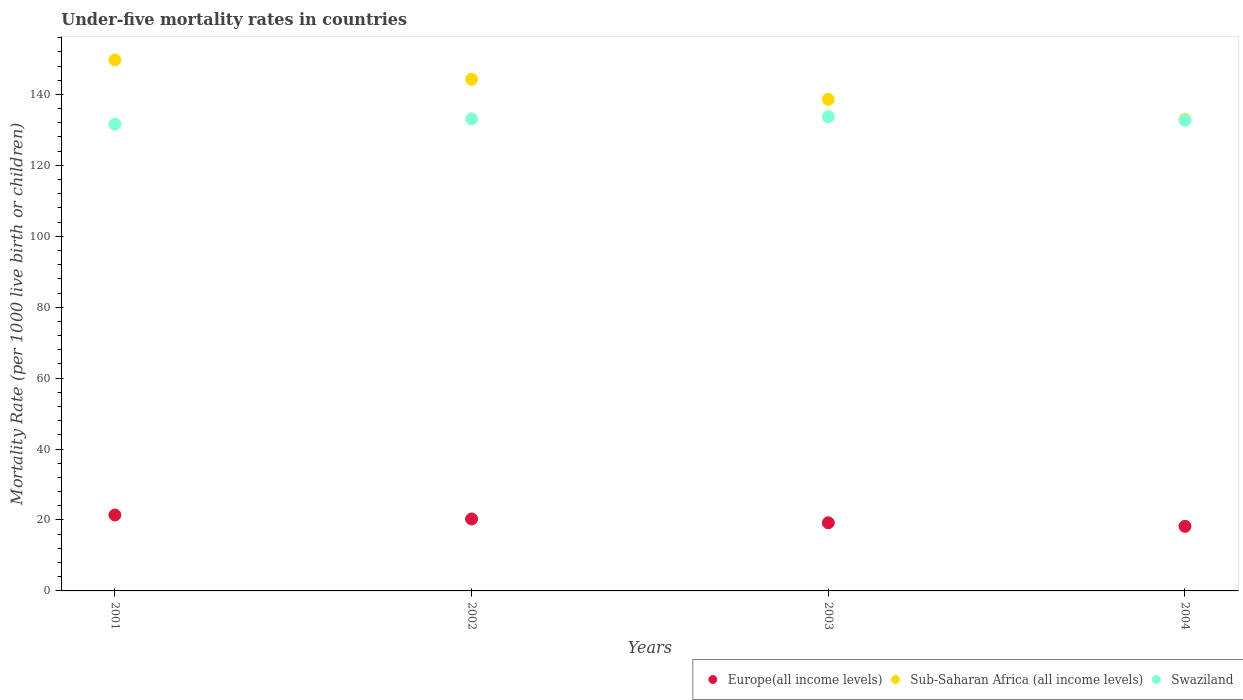How many different coloured dotlines are there?
Provide a succinct answer. 3. Is the number of dotlines equal to the number of legend labels?
Provide a succinct answer. Yes. What is the under-five mortality rate in Europe(all income levels) in 2001?
Offer a terse response. 21.41. Across all years, what is the maximum under-five mortality rate in Europe(all income levels)?
Ensure brevity in your answer.  21.41. Across all years, what is the minimum under-five mortality rate in Swaziland?
Provide a short and direct response. 131.6. In which year was the under-five mortality rate in Europe(all income levels) maximum?
Make the answer very short. 2001. In which year was the under-five mortality rate in Europe(all income levels) minimum?
Offer a terse response. 2004. What is the total under-five mortality rate in Europe(all income levels) in the graph?
Offer a terse response. 79.12. What is the difference between the under-five mortality rate in Sub-Saharan Africa (all income levels) in 2001 and that in 2004?
Your answer should be compact. 16.84. What is the difference between the under-five mortality rate in Sub-Saharan Africa (all income levels) in 2004 and the under-five mortality rate in Swaziland in 2003?
Give a very brief answer. -0.8. What is the average under-five mortality rate in Swaziland per year?
Provide a succinct answer. 132.77. In the year 2001, what is the difference between the under-five mortality rate in Europe(all income levels) and under-five mortality rate in Sub-Saharan Africa (all income levels)?
Provide a succinct answer. -128.33. In how many years, is the under-five mortality rate in Europe(all income levels) greater than 44?
Ensure brevity in your answer.  0. What is the ratio of the under-five mortality rate in Sub-Saharan Africa (all income levels) in 2002 to that in 2003?
Your answer should be very brief. 1.04. What is the difference between the highest and the second highest under-five mortality rate in Europe(all income levels)?
Provide a short and direct response. 1.12. What is the difference between the highest and the lowest under-five mortality rate in Sub-Saharan Africa (all income levels)?
Offer a terse response. 16.84. In how many years, is the under-five mortality rate in Swaziland greater than the average under-five mortality rate in Swaziland taken over all years?
Offer a terse response. 2. Is it the case that in every year, the sum of the under-five mortality rate in Swaziland and under-five mortality rate in Sub-Saharan Africa (all income levels)  is greater than the under-five mortality rate in Europe(all income levels)?
Ensure brevity in your answer.  Yes. Does the under-five mortality rate in Sub-Saharan Africa (all income levels) monotonically increase over the years?
Give a very brief answer. No. Is the under-five mortality rate in Swaziland strictly less than the under-five mortality rate in Sub-Saharan Africa (all income levels) over the years?
Offer a terse response. Yes. How many dotlines are there?
Make the answer very short. 3. How many years are there in the graph?
Keep it short and to the point. 4. Does the graph contain any zero values?
Give a very brief answer. No. How many legend labels are there?
Make the answer very short. 3. How are the legend labels stacked?
Keep it short and to the point. Horizontal. What is the title of the graph?
Your response must be concise. Under-five mortality rates in countries. What is the label or title of the Y-axis?
Your response must be concise. Mortality Rate (per 1000 live birth or children). What is the Mortality Rate (per 1000 live birth or children) in Europe(all income levels) in 2001?
Ensure brevity in your answer.  21.41. What is the Mortality Rate (per 1000 live birth or children) of Sub-Saharan Africa (all income levels) in 2001?
Your answer should be compact. 149.74. What is the Mortality Rate (per 1000 live birth or children) in Swaziland in 2001?
Provide a short and direct response. 131.6. What is the Mortality Rate (per 1000 live birth or children) of Europe(all income levels) in 2002?
Keep it short and to the point. 20.29. What is the Mortality Rate (per 1000 live birth or children) of Sub-Saharan Africa (all income levels) in 2002?
Your response must be concise. 144.27. What is the Mortality Rate (per 1000 live birth or children) of Swaziland in 2002?
Provide a short and direct response. 133.1. What is the Mortality Rate (per 1000 live birth or children) in Europe(all income levels) in 2003?
Make the answer very short. 19.22. What is the Mortality Rate (per 1000 live birth or children) of Sub-Saharan Africa (all income levels) in 2003?
Give a very brief answer. 138.61. What is the Mortality Rate (per 1000 live birth or children) in Swaziland in 2003?
Keep it short and to the point. 133.7. What is the Mortality Rate (per 1000 live birth or children) of Europe(all income levels) in 2004?
Ensure brevity in your answer.  18.21. What is the Mortality Rate (per 1000 live birth or children) in Sub-Saharan Africa (all income levels) in 2004?
Ensure brevity in your answer.  132.9. What is the Mortality Rate (per 1000 live birth or children) of Swaziland in 2004?
Give a very brief answer. 132.7. Across all years, what is the maximum Mortality Rate (per 1000 live birth or children) of Europe(all income levels)?
Provide a succinct answer. 21.41. Across all years, what is the maximum Mortality Rate (per 1000 live birth or children) in Sub-Saharan Africa (all income levels)?
Keep it short and to the point. 149.74. Across all years, what is the maximum Mortality Rate (per 1000 live birth or children) of Swaziland?
Give a very brief answer. 133.7. Across all years, what is the minimum Mortality Rate (per 1000 live birth or children) of Europe(all income levels)?
Offer a terse response. 18.21. Across all years, what is the minimum Mortality Rate (per 1000 live birth or children) of Sub-Saharan Africa (all income levels)?
Provide a short and direct response. 132.9. Across all years, what is the minimum Mortality Rate (per 1000 live birth or children) of Swaziland?
Keep it short and to the point. 131.6. What is the total Mortality Rate (per 1000 live birth or children) in Europe(all income levels) in the graph?
Give a very brief answer. 79.12. What is the total Mortality Rate (per 1000 live birth or children) in Sub-Saharan Africa (all income levels) in the graph?
Ensure brevity in your answer.  565.52. What is the total Mortality Rate (per 1000 live birth or children) of Swaziland in the graph?
Provide a short and direct response. 531.1. What is the difference between the Mortality Rate (per 1000 live birth or children) in Europe(all income levels) in 2001 and that in 2002?
Your answer should be compact. 1.12. What is the difference between the Mortality Rate (per 1000 live birth or children) of Sub-Saharan Africa (all income levels) in 2001 and that in 2002?
Give a very brief answer. 5.47. What is the difference between the Mortality Rate (per 1000 live birth or children) in Swaziland in 2001 and that in 2002?
Your response must be concise. -1.5. What is the difference between the Mortality Rate (per 1000 live birth or children) in Europe(all income levels) in 2001 and that in 2003?
Give a very brief answer. 2.19. What is the difference between the Mortality Rate (per 1000 live birth or children) of Sub-Saharan Africa (all income levels) in 2001 and that in 2003?
Keep it short and to the point. 11.13. What is the difference between the Mortality Rate (per 1000 live birth or children) of Europe(all income levels) in 2001 and that in 2004?
Keep it short and to the point. 3.2. What is the difference between the Mortality Rate (per 1000 live birth or children) of Sub-Saharan Africa (all income levels) in 2001 and that in 2004?
Give a very brief answer. 16.84. What is the difference between the Mortality Rate (per 1000 live birth or children) in Swaziland in 2001 and that in 2004?
Your answer should be very brief. -1.1. What is the difference between the Mortality Rate (per 1000 live birth or children) of Europe(all income levels) in 2002 and that in 2003?
Your answer should be compact. 1.07. What is the difference between the Mortality Rate (per 1000 live birth or children) in Sub-Saharan Africa (all income levels) in 2002 and that in 2003?
Ensure brevity in your answer.  5.66. What is the difference between the Mortality Rate (per 1000 live birth or children) in Europe(all income levels) in 2002 and that in 2004?
Give a very brief answer. 2.09. What is the difference between the Mortality Rate (per 1000 live birth or children) of Sub-Saharan Africa (all income levels) in 2002 and that in 2004?
Your response must be concise. 11.37. What is the difference between the Mortality Rate (per 1000 live birth or children) of Swaziland in 2002 and that in 2004?
Keep it short and to the point. 0.4. What is the difference between the Mortality Rate (per 1000 live birth or children) in Europe(all income levels) in 2003 and that in 2004?
Provide a succinct answer. 1.01. What is the difference between the Mortality Rate (per 1000 live birth or children) in Sub-Saharan Africa (all income levels) in 2003 and that in 2004?
Give a very brief answer. 5.72. What is the difference between the Mortality Rate (per 1000 live birth or children) in Europe(all income levels) in 2001 and the Mortality Rate (per 1000 live birth or children) in Sub-Saharan Africa (all income levels) in 2002?
Give a very brief answer. -122.86. What is the difference between the Mortality Rate (per 1000 live birth or children) of Europe(all income levels) in 2001 and the Mortality Rate (per 1000 live birth or children) of Swaziland in 2002?
Offer a terse response. -111.69. What is the difference between the Mortality Rate (per 1000 live birth or children) in Sub-Saharan Africa (all income levels) in 2001 and the Mortality Rate (per 1000 live birth or children) in Swaziland in 2002?
Keep it short and to the point. 16.64. What is the difference between the Mortality Rate (per 1000 live birth or children) in Europe(all income levels) in 2001 and the Mortality Rate (per 1000 live birth or children) in Sub-Saharan Africa (all income levels) in 2003?
Provide a succinct answer. -117.2. What is the difference between the Mortality Rate (per 1000 live birth or children) of Europe(all income levels) in 2001 and the Mortality Rate (per 1000 live birth or children) of Swaziland in 2003?
Ensure brevity in your answer.  -112.29. What is the difference between the Mortality Rate (per 1000 live birth or children) in Sub-Saharan Africa (all income levels) in 2001 and the Mortality Rate (per 1000 live birth or children) in Swaziland in 2003?
Your response must be concise. 16.04. What is the difference between the Mortality Rate (per 1000 live birth or children) of Europe(all income levels) in 2001 and the Mortality Rate (per 1000 live birth or children) of Sub-Saharan Africa (all income levels) in 2004?
Your response must be concise. -111.49. What is the difference between the Mortality Rate (per 1000 live birth or children) in Europe(all income levels) in 2001 and the Mortality Rate (per 1000 live birth or children) in Swaziland in 2004?
Make the answer very short. -111.29. What is the difference between the Mortality Rate (per 1000 live birth or children) of Sub-Saharan Africa (all income levels) in 2001 and the Mortality Rate (per 1000 live birth or children) of Swaziland in 2004?
Make the answer very short. 17.04. What is the difference between the Mortality Rate (per 1000 live birth or children) in Europe(all income levels) in 2002 and the Mortality Rate (per 1000 live birth or children) in Sub-Saharan Africa (all income levels) in 2003?
Give a very brief answer. -118.32. What is the difference between the Mortality Rate (per 1000 live birth or children) of Europe(all income levels) in 2002 and the Mortality Rate (per 1000 live birth or children) of Swaziland in 2003?
Ensure brevity in your answer.  -113.41. What is the difference between the Mortality Rate (per 1000 live birth or children) of Sub-Saharan Africa (all income levels) in 2002 and the Mortality Rate (per 1000 live birth or children) of Swaziland in 2003?
Keep it short and to the point. 10.57. What is the difference between the Mortality Rate (per 1000 live birth or children) of Europe(all income levels) in 2002 and the Mortality Rate (per 1000 live birth or children) of Sub-Saharan Africa (all income levels) in 2004?
Keep it short and to the point. -112.61. What is the difference between the Mortality Rate (per 1000 live birth or children) in Europe(all income levels) in 2002 and the Mortality Rate (per 1000 live birth or children) in Swaziland in 2004?
Keep it short and to the point. -112.41. What is the difference between the Mortality Rate (per 1000 live birth or children) in Sub-Saharan Africa (all income levels) in 2002 and the Mortality Rate (per 1000 live birth or children) in Swaziland in 2004?
Ensure brevity in your answer.  11.57. What is the difference between the Mortality Rate (per 1000 live birth or children) in Europe(all income levels) in 2003 and the Mortality Rate (per 1000 live birth or children) in Sub-Saharan Africa (all income levels) in 2004?
Your response must be concise. -113.68. What is the difference between the Mortality Rate (per 1000 live birth or children) of Europe(all income levels) in 2003 and the Mortality Rate (per 1000 live birth or children) of Swaziland in 2004?
Give a very brief answer. -113.48. What is the difference between the Mortality Rate (per 1000 live birth or children) in Sub-Saharan Africa (all income levels) in 2003 and the Mortality Rate (per 1000 live birth or children) in Swaziland in 2004?
Offer a very short reply. 5.91. What is the average Mortality Rate (per 1000 live birth or children) in Europe(all income levels) per year?
Provide a succinct answer. 19.78. What is the average Mortality Rate (per 1000 live birth or children) of Sub-Saharan Africa (all income levels) per year?
Offer a terse response. 141.38. What is the average Mortality Rate (per 1000 live birth or children) in Swaziland per year?
Your answer should be compact. 132.78. In the year 2001, what is the difference between the Mortality Rate (per 1000 live birth or children) in Europe(all income levels) and Mortality Rate (per 1000 live birth or children) in Sub-Saharan Africa (all income levels)?
Offer a very short reply. -128.33. In the year 2001, what is the difference between the Mortality Rate (per 1000 live birth or children) in Europe(all income levels) and Mortality Rate (per 1000 live birth or children) in Swaziland?
Provide a succinct answer. -110.19. In the year 2001, what is the difference between the Mortality Rate (per 1000 live birth or children) of Sub-Saharan Africa (all income levels) and Mortality Rate (per 1000 live birth or children) of Swaziland?
Keep it short and to the point. 18.14. In the year 2002, what is the difference between the Mortality Rate (per 1000 live birth or children) in Europe(all income levels) and Mortality Rate (per 1000 live birth or children) in Sub-Saharan Africa (all income levels)?
Make the answer very short. -123.98. In the year 2002, what is the difference between the Mortality Rate (per 1000 live birth or children) of Europe(all income levels) and Mortality Rate (per 1000 live birth or children) of Swaziland?
Your answer should be very brief. -112.81. In the year 2002, what is the difference between the Mortality Rate (per 1000 live birth or children) in Sub-Saharan Africa (all income levels) and Mortality Rate (per 1000 live birth or children) in Swaziland?
Make the answer very short. 11.17. In the year 2003, what is the difference between the Mortality Rate (per 1000 live birth or children) of Europe(all income levels) and Mortality Rate (per 1000 live birth or children) of Sub-Saharan Africa (all income levels)?
Make the answer very short. -119.4. In the year 2003, what is the difference between the Mortality Rate (per 1000 live birth or children) of Europe(all income levels) and Mortality Rate (per 1000 live birth or children) of Swaziland?
Offer a terse response. -114.48. In the year 2003, what is the difference between the Mortality Rate (per 1000 live birth or children) in Sub-Saharan Africa (all income levels) and Mortality Rate (per 1000 live birth or children) in Swaziland?
Give a very brief answer. 4.91. In the year 2004, what is the difference between the Mortality Rate (per 1000 live birth or children) in Europe(all income levels) and Mortality Rate (per 1000 live birth or children) in Sub-Saharan Africa (all income levels)?
Your response must be concise. -114.69. In the year 2004, what is the difference between the Mortality Rate (per 1000 live birth or children) of Europe(all income levels) and Mortality Rate (per 1000 live birth or children) of Swaziland?
Your answer should be compact. -114.49. In the year 2004, what is the difference between the Mortality Rate (per 1000 live birth or children) of Sub-Saharan Africa (all income levels) and Mortality Rate (per 1000 live birth or children) of Swaziland?
Provide a succinct answer. 0.2. What is the ratio of the Mortality Rate (per 1000 live birth or children) in Europe(all income levels) in 2001 to that in 2002?
Your answer should be compact. 1.06. What is the ratio of the Mortality Rate (per 1000 live birth or children) in Sub-Saharan Africa (all income levels) in 2001 to that in 2002?
Your answer should be very brief. 1.04. What is the ratio of the Mortality Rate (per 1000 live birth or children) in Swaziland in 2001 to that in 2002?
Give a very brief answer. 0.99. What is the ratio of the Mortality Rate (per 1000 live birth or children) in Europe(all income levels) in 2001 to that in 2003?
Keep it short and to the point. 1.11. What is the ratio of the Mortality Rate (per 1000 live birth or children) in Sub-Saharan Africa (all income levels) in 2001 to that in 2003?
Offer a terse response. 1.08. What is the ratio of the Mortality Rate (per 1000 live birth or children) of Swaziland in 2001 to that in 2003?
Your answer should be compact. 0.98. What is the ratio of the Mortality Rate (per 1000 live birth or children) of Europe(all income levels) in 2001 to that in 2004?
Your response must be concise. 1.18. What is the ratio of the Mortality Rate (per 1000 live birth or children) of Sub-Saharan Africa (all income levels) in 2001 to that in 2004?
Provide a short and direct response. 1.13. What is the ratio of the Mortality Rate (per 1000 live birth or children) in Europe(all income levels) in 2002 to that in 2003?
Your answer should be compact. 1.06. What is the ratio of the Mortality Rate (per 1000 live birth or children) of Sub-Saharan Africa (all income levels) in 2002 to that in 2003?
Make the answer very short. 1.04. What is the ratio of the Mortality Rate (per 1000 live birth or children) in Europe(all income levels) in 2002 to that in 2004?
Give a very brief answer. 1.11. What is the ratio of the Mortality Rate (per 1000 live birth or children) in Sub-Saharan Africa (all income levels) in 2002 to that in 2004?
Provide a succinct answer. 1.09. What is the ratio of the Mortality Rate (per 1000 live birth or children) in Europe(all income levels) in 2003 to that in 2004?
Make the answer very short. 1.06. What is the ratio of the Mortality Rate (per 1000 live birth or children) of Sub-Saharan Africa (all income levels) in 2003 to that in 2004?
Ensure brevity in your answer.  1.04. What is the ratio of the Mortality Rate (per 1000 live birth or children) of Swaziland in 2003 to that in 2004?
Provide a short and direct response. 1.01. What is the difference between the highest and the second highest Mortality Rate (per 1000 live birth or children) of Europe(all income levels)?
Your answer should be very brief. 1.12. What is the difference between the highest and the second highest Mortality Rate (per 1000 live birth or children) of Sub-Saharan Africa (all income levels)?
Your answer should be compact. 5.47. What is the difference between the highest and the lowest Mortality Rate (per 1000 live birth or children) in Europe(all income levels)?
Make the answer very short. 3.2. What is the difference between the highest and the lowest Mortality Rate (per 1000 live birth or children) in Sub-Saharan Africa (all income levels)?
Offer a very short reply. 16.84. 